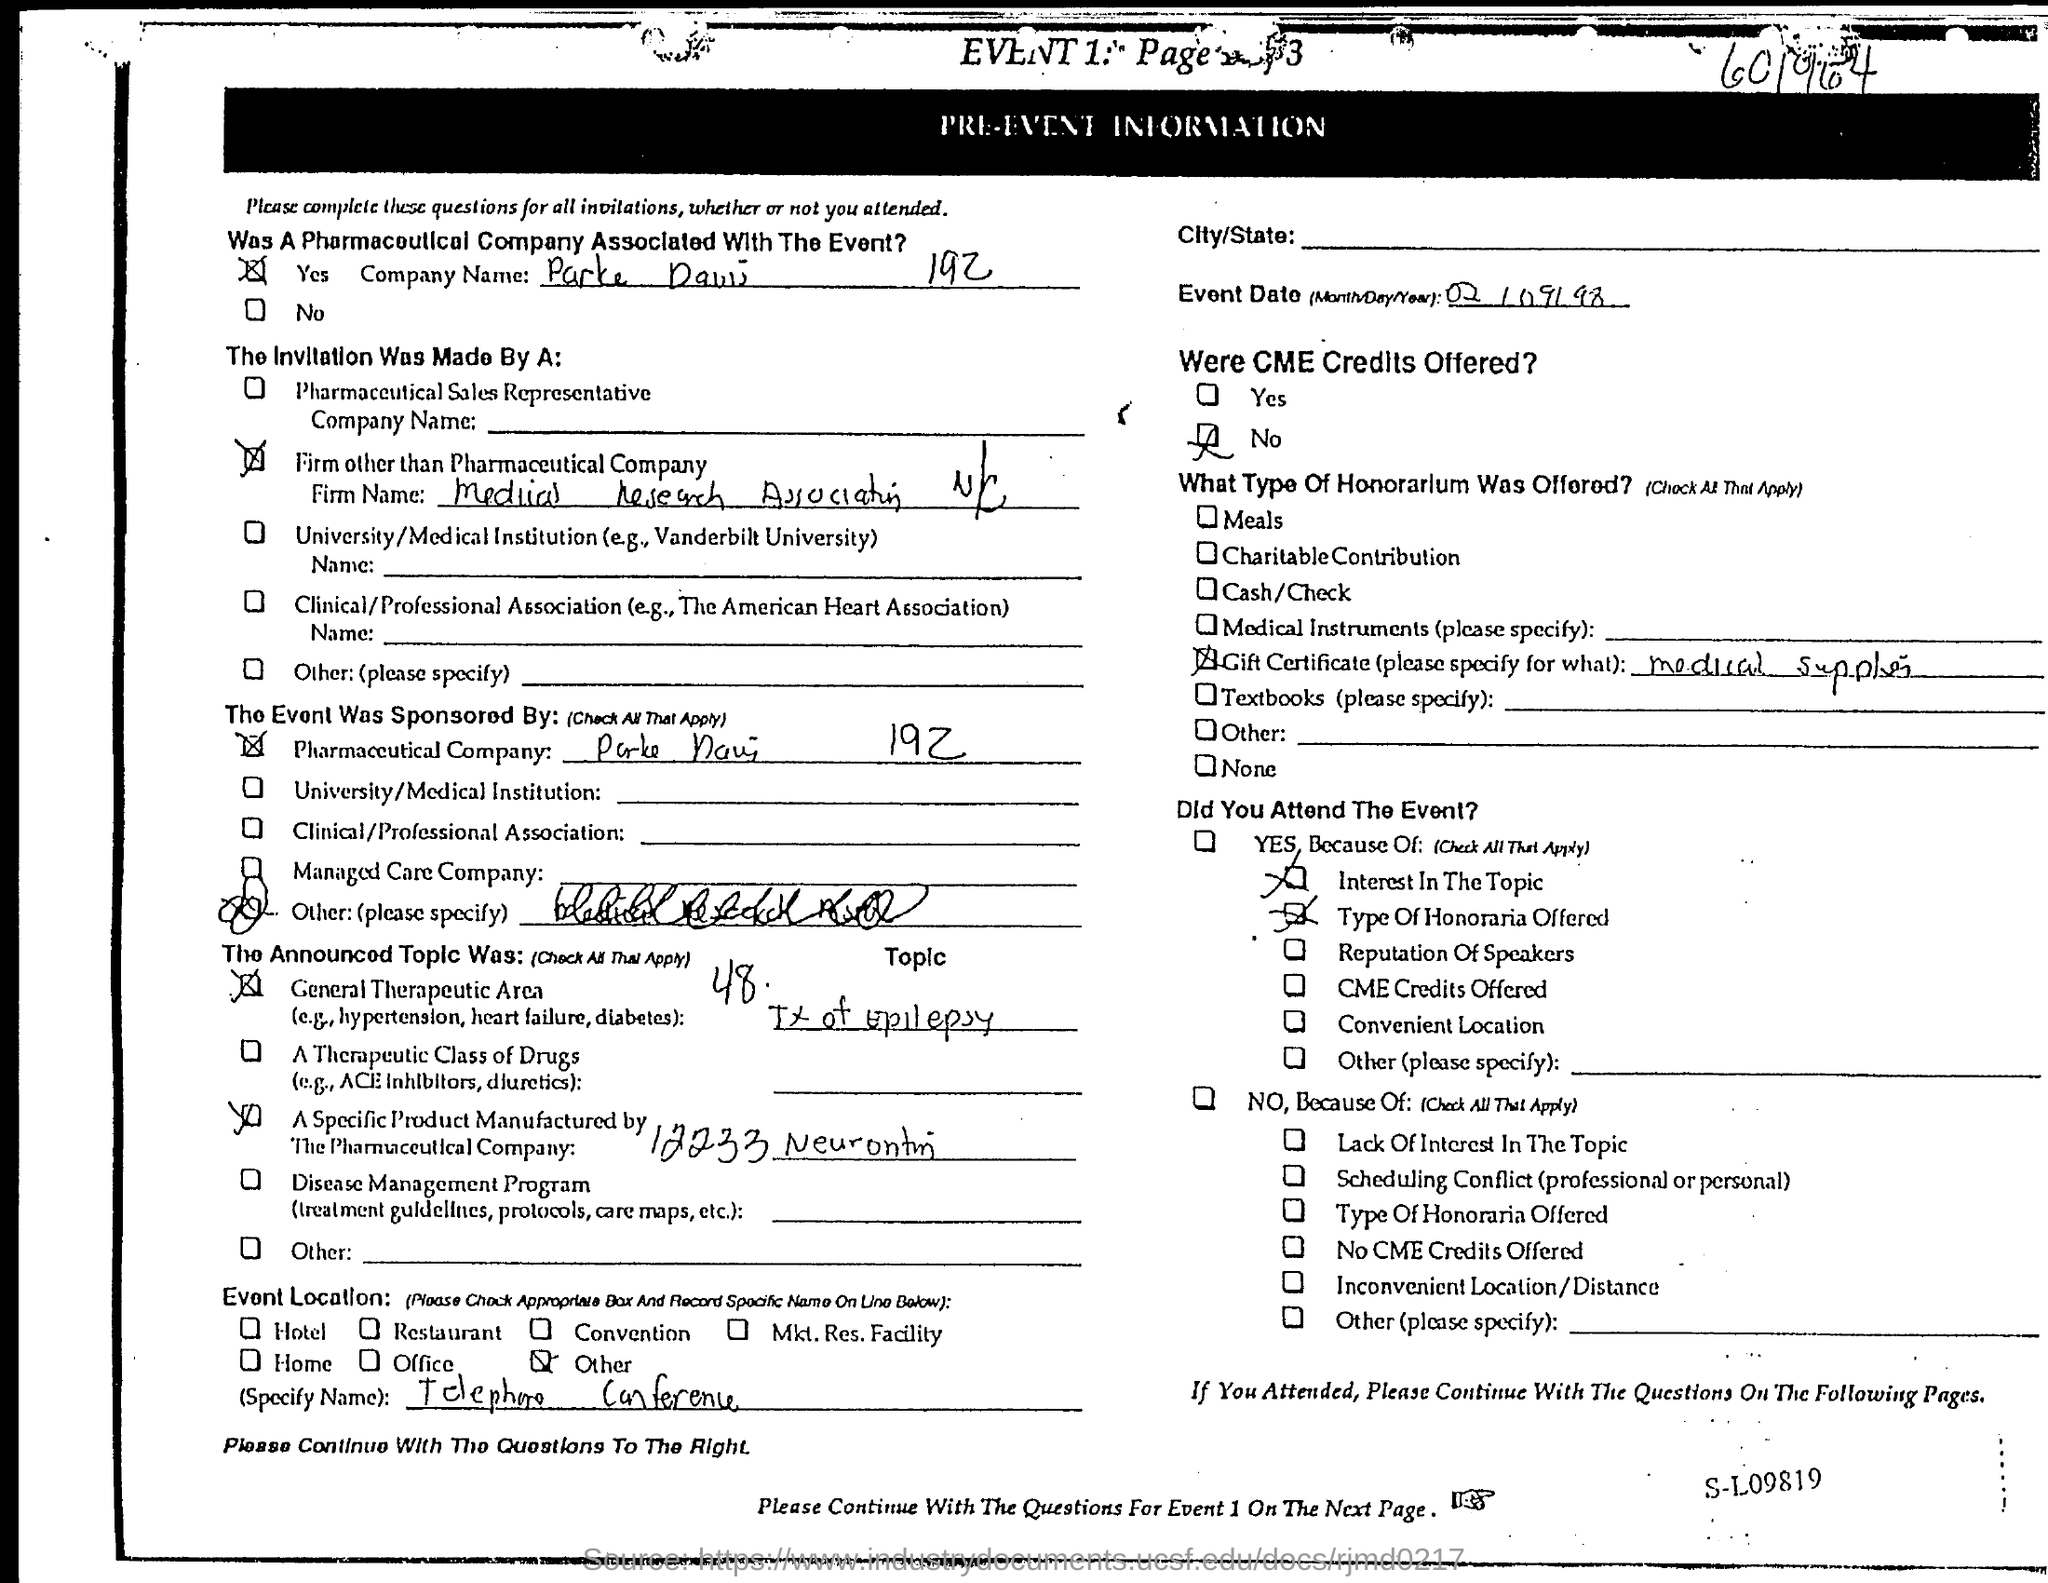The Invitation Was Made By A?
Make the answer very short. Firm other than Pharmaceutical Company. What is the Event Date?
Ensure brevity in your answer.  02/09/98. Were CME Credits Offered?
Give a very brief answer. No. 